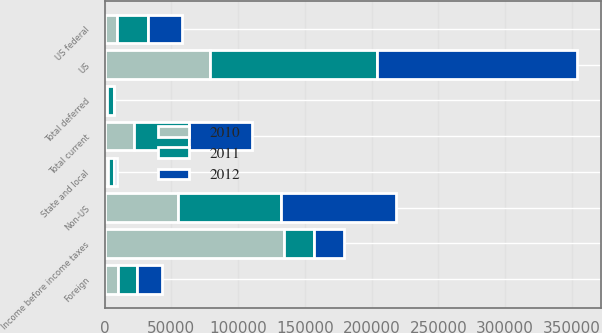Convert chart. <chart><loc_0><loc_0><loc_500><loc_500><stacked_bar_chart><ecel><fcel>US<fcel>Non-US<fcel>Income before income taxes<fcel>US federal<fcel>State and local<fcel>Foreign<fcel>Total current<fcel>Total deferred<nl><fcel>2012<fcel>150023<fcel>85573<fcel>22695.5<fcel>25290<fcel>2508<fcel>18889<fcel>46687<fcel>339<nl><fcel>2011<fcel>124915<fcel>77269<fcel>22695.5<fcel>23327<fcel>4236<fcel>13845<fcel>41408<fcel>5357<nl><fcel>2010<fcel>78933<fcel>55152<fcel>134085<fcel>9078<fcel>2645<fcel>10341<fcel>22064<fcel>1678<nl></chart> 